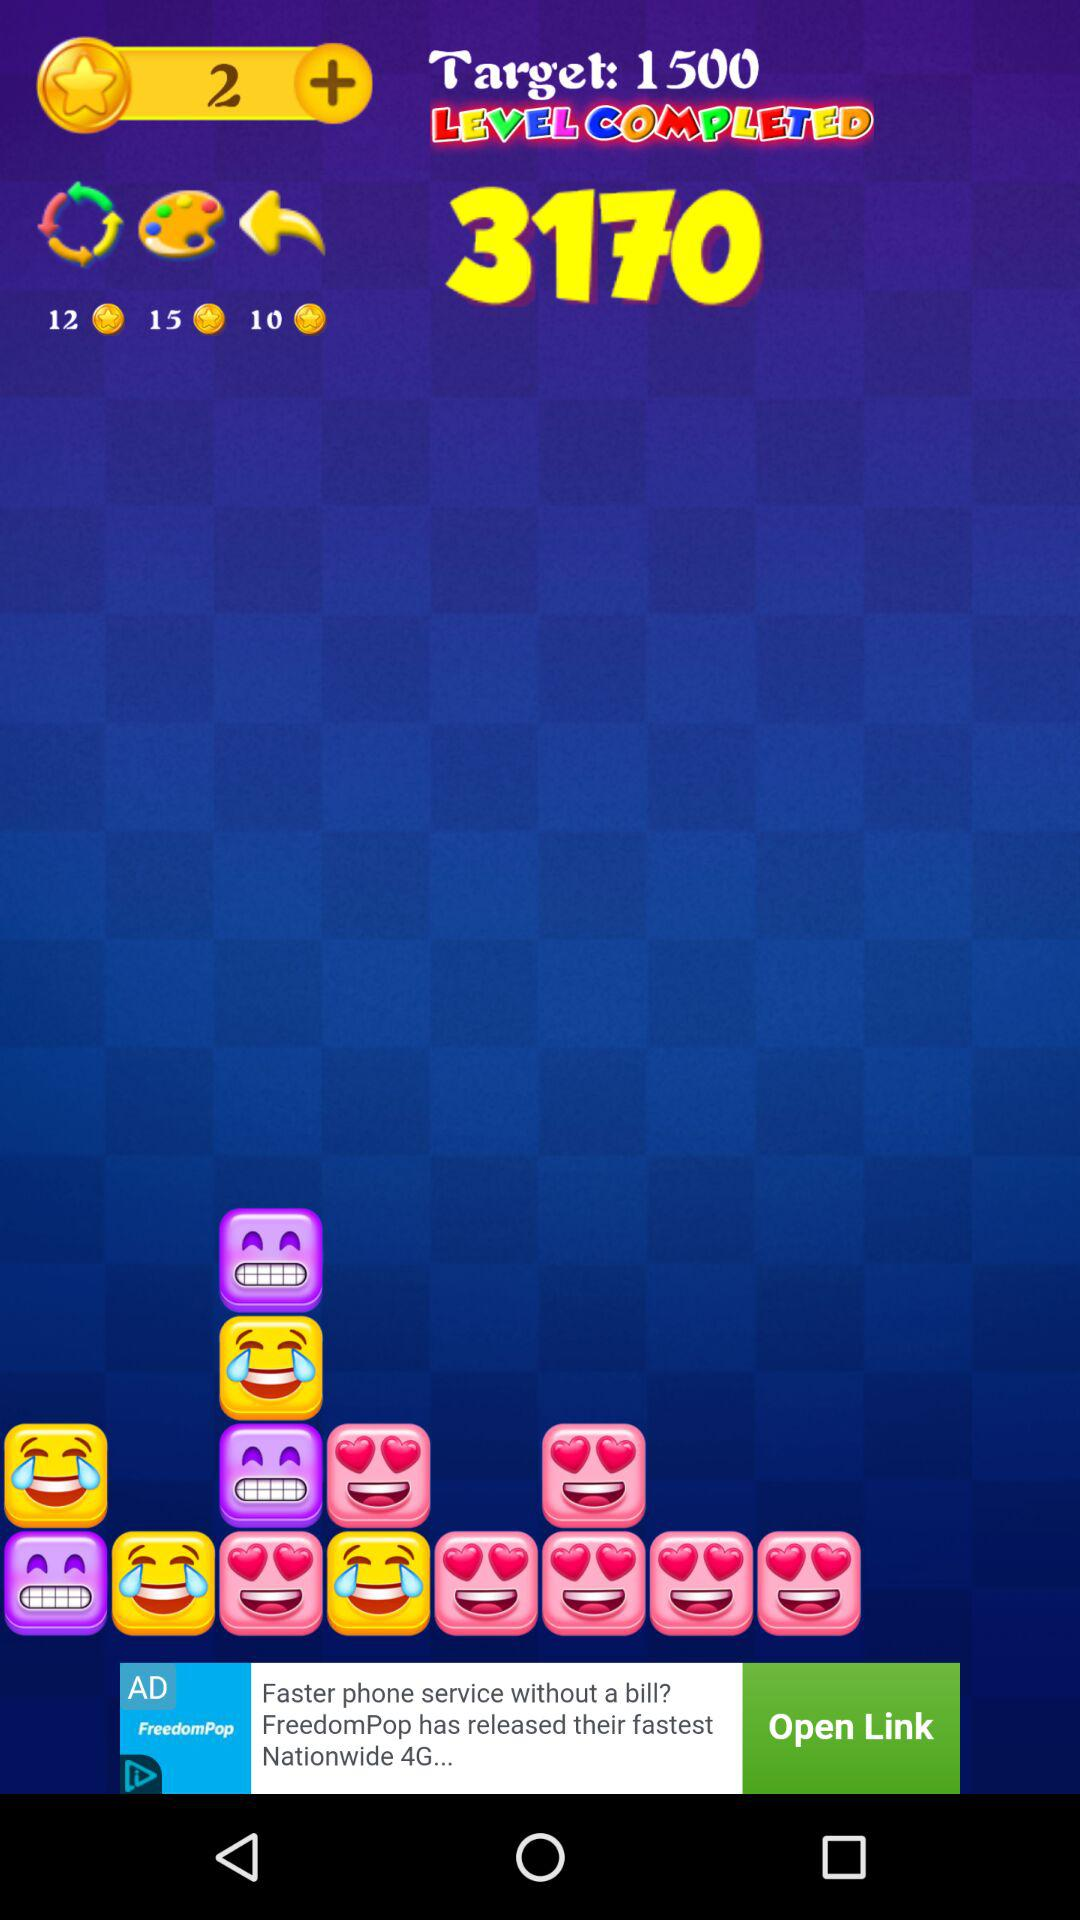What's the "Target"? The target is 1500. 